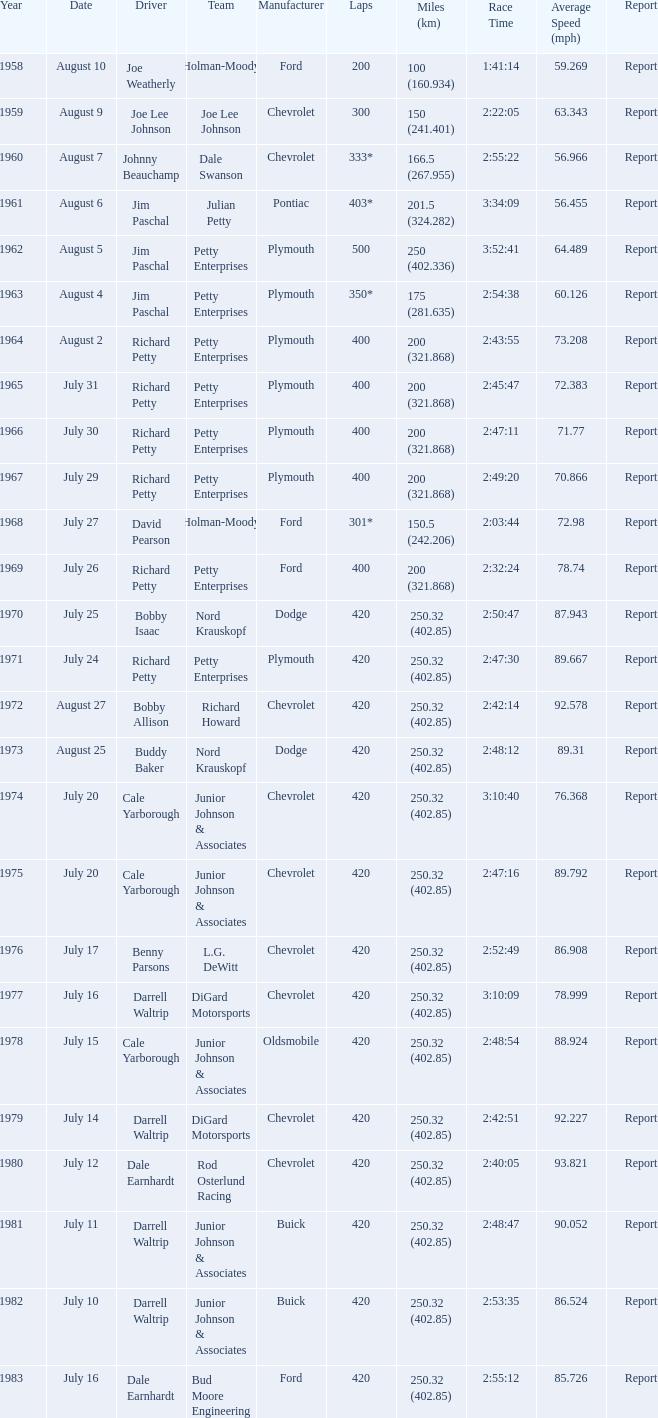How many races did Cale Yarborough win at an average speed of 88.924 mph? 1.0. 